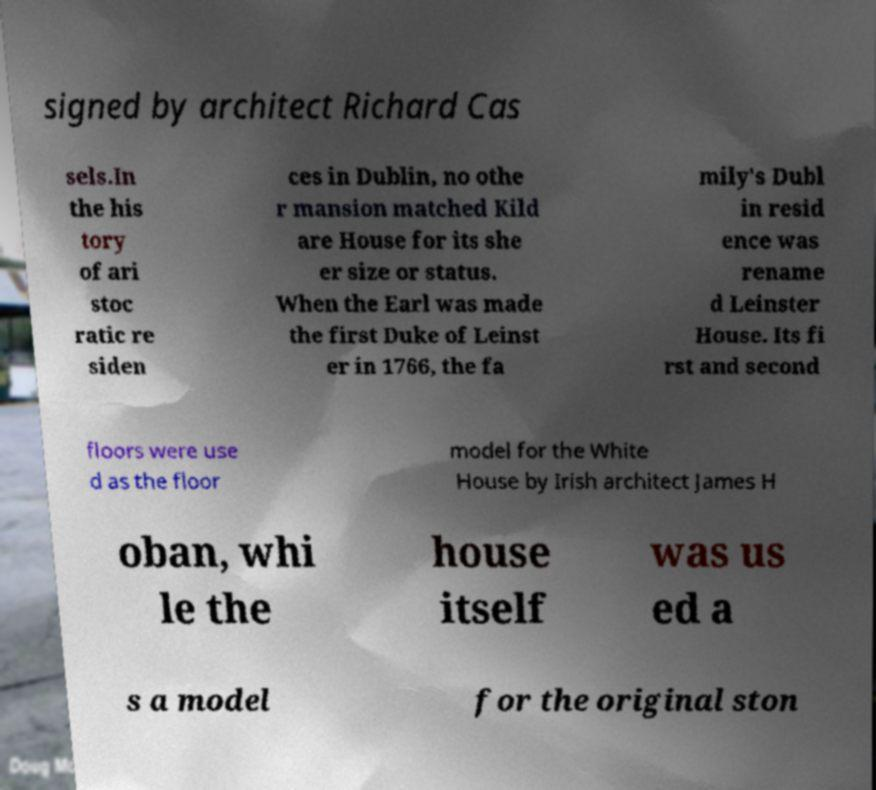Could you extract and type out the text from this image? signed by architect Richard Cas sels.In the his tory of ari stoc ratic re siden ces in Dublin, no othe r mansion matched Kild are House for its she er size or status. When the Earl was made the first Duke of Leinst er in 1766, the fa mily's Dubl in resid ence was rename d Leinster House. Its fi rst and second floors were use d as the floor model for the White House by Irish architect James H oban, whi le the house itself was us ed a s a model for the original ston 